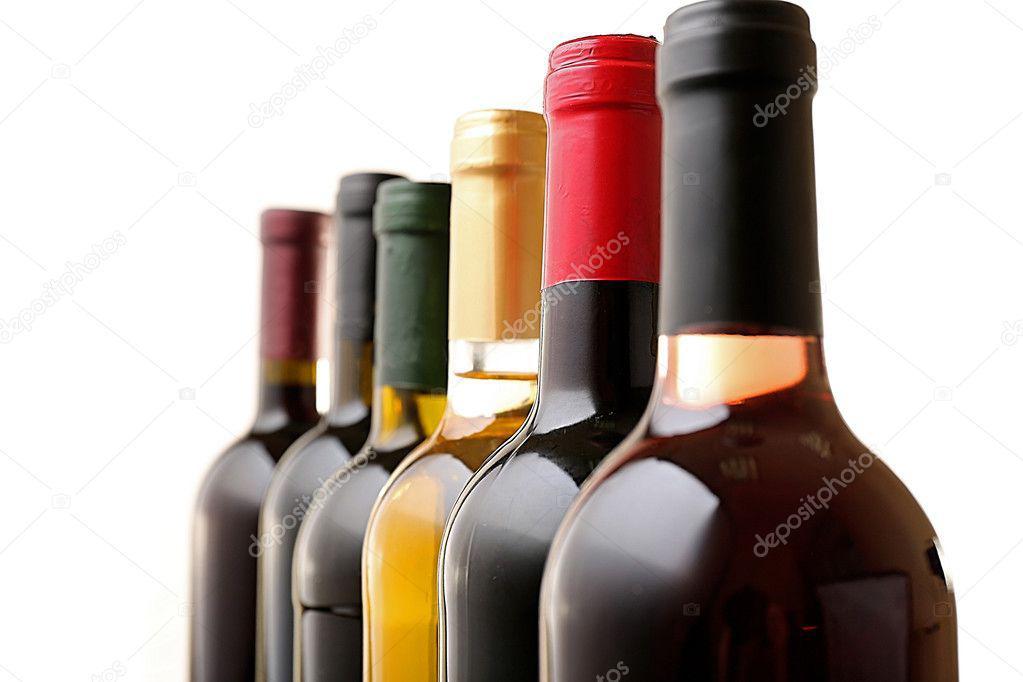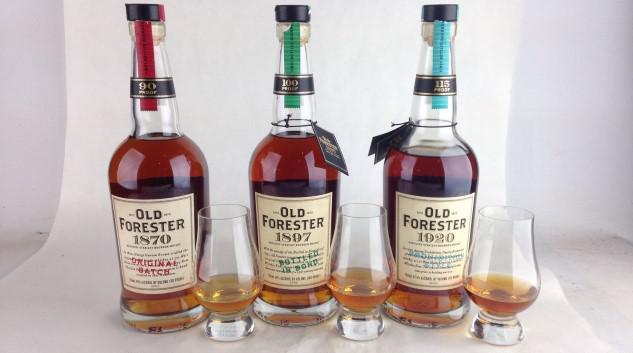The first image is the image on the left, the second image is the image on the right. Considering the images on both sides, is "There are no more than four bottles in one of the images." valid? Answer yes or no. Yes. The first image is the image on the left, the second image is the image on the right. Assess this claim about the two images: "There are more bottles in the right image than in the left image.". Correct or not? Answer yes or no. No. 